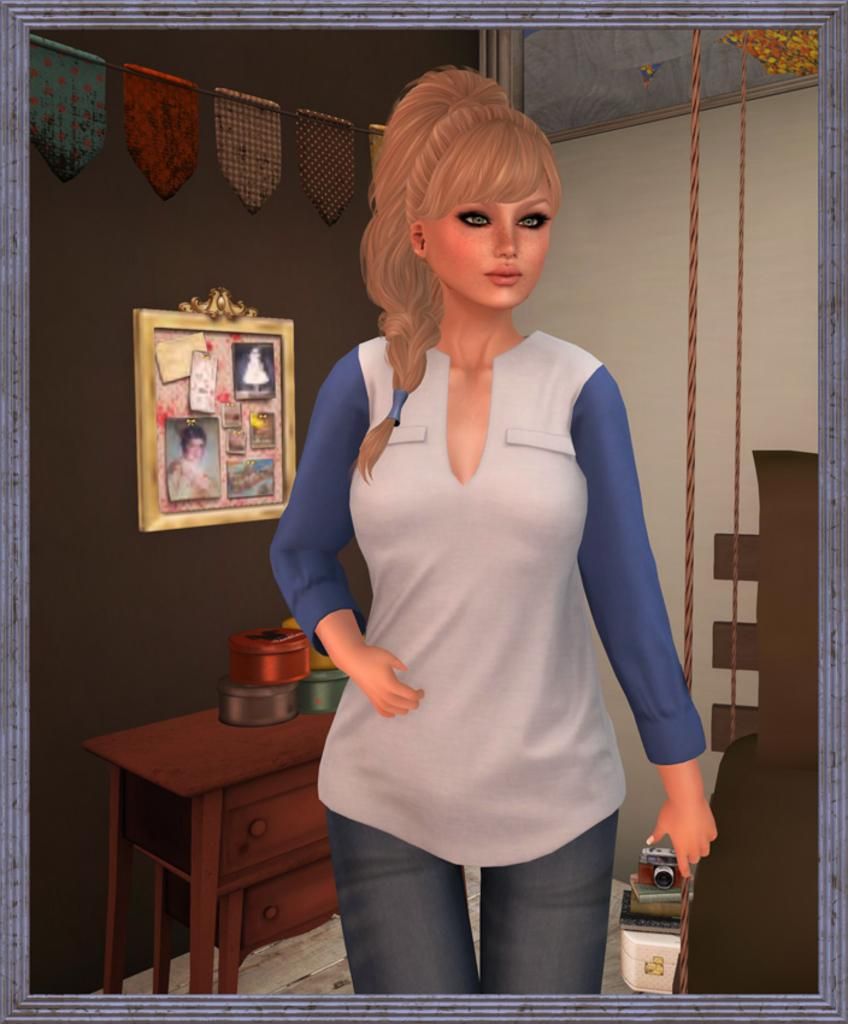Who is the main subject in the image? There is a lady in the image. What is the lady holding in the image? The lady is holding a camera. What can be seen in the background of the image? There is a wall, a photo frame, and a table in the background of the image. How many cents are visible on the table in the image? There are no cents visible on the table in the image. What type of lamp is present on the wall in the image? There is no lamp present on the wall in the image. 